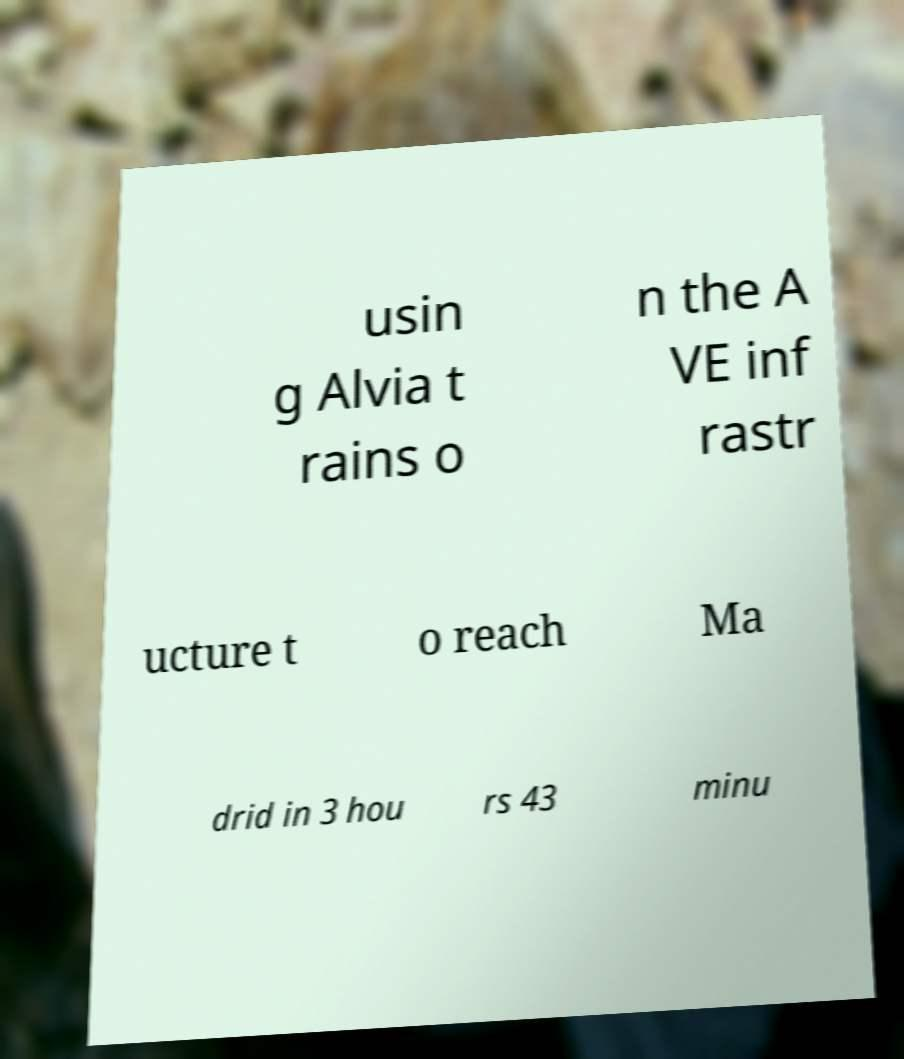Could you extract and type out the text from this image? usin g Alvia t rains o n the A VE inf rastr ucture t o reach Ma drid in 3 hou rs 43 minu 